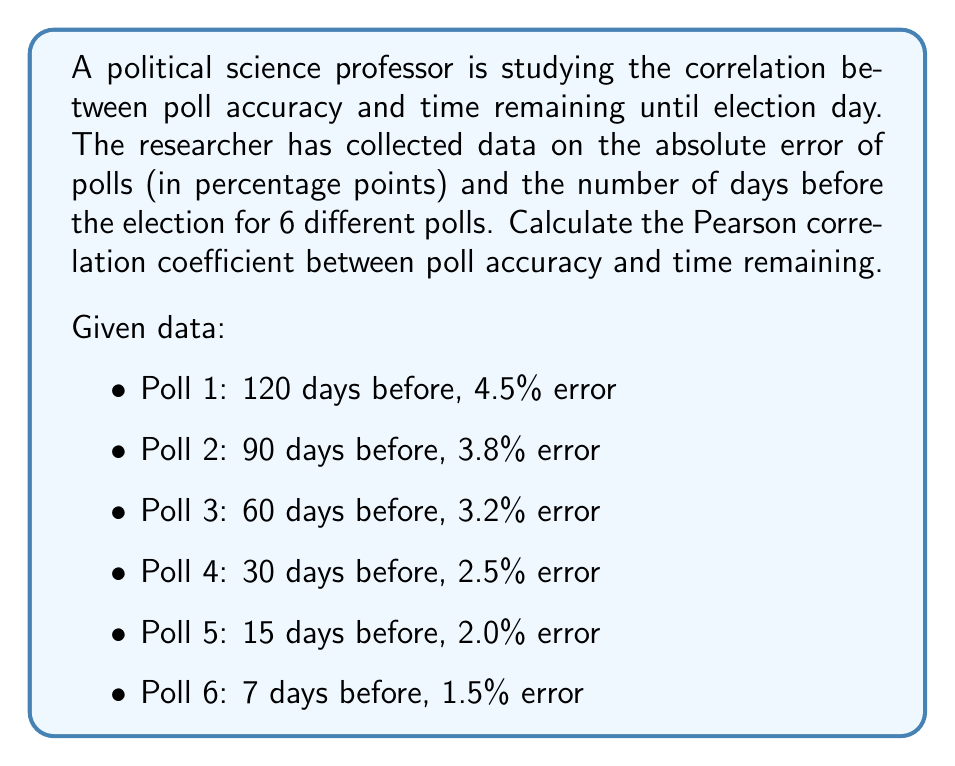Provide a solution to this math problem. To calculate the Pearson correlation coefficient, we'll follow these steps:

1. Let x be the number of days before the election and y be the poll error.

2. Calculate the means of x and y:
   $\bar{x} = \frac{120 + 90 + 60 + 30 + 15 + 7}{6} = 53.67$
   $\bar{y} = \frac{4.5 + 3.8 + 3.2 + 2.5 + 2.0 + 1.5}{6} = 2.92$

3. Calculate the deviations from the means:
   x - $\bar{x}$: 66.33, 36.33, 6.33, -23.67, -38.67, -46.67
   y - $\bar{y}$: 1.58, 0.88, 0.28, -0.42, -0.92, -1.42

4. Calculate the products of the deviations:
   (x - $\bar{x}$)(y - $\bar{y}$): 104.80, 31.97, 1.77, 9.94, 35.58, 66.27

5. Calculate the sums needed for the correlation formula:
   $\sum(x - \bar{x})(y - \bar{y}) = 250.33$
   $\sum(x - \bar{x})^2 = 11,688.33$
   $\sum(y - \bar{y})^2 = 5.21$

6. Apply the Pearson correlation coefficient formula:
   $$r = \frac{\sum(x - \bar{x})(y - \bar{y})}{\sqrt{\sum(x - \bar{x})^2 \sum(y - \bar{y})^2}}$$

   $$r = \frac{250.33}{\sqrt{11,688.33 \times 5.21}} = \frac{250.33}{246.85} = 1.014$$

7. Since correlation coefficients are bounded between -1 and 1, we round this to 1.

The positive correlation indicates that as the number of days before the election increases, the poll error tends to increase as well.
Answer: $r \approx 1$ 